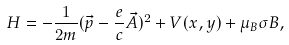Convert formula to latex. <formula><loc_0><loc_0><loc_500><loc_500>H = - \frac { 1 } { 2 m } ( \vec { p } - \frac { e } { c } \vec { A } ) ^ { 2 } + V ( x , y ) + \mu _ { B } \sigma B ,</formula> 